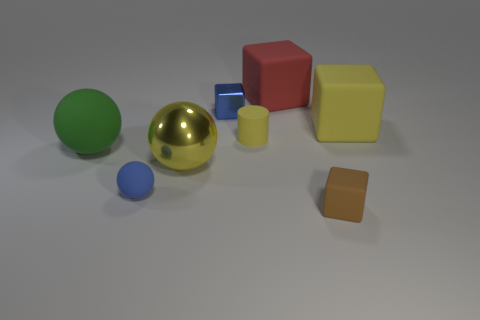What number of rubber objects are either big yellow things or big blocks?
Make the answer very short. 2. What number of other big metal things are the same color as the big metal object?
Your response must be concise. 0. What is the material of the tiny cube that is on the right side of the shiny object behind the large green object?
Give a very brief answer. Rubber. The cylinder has what size?
Make the answer very short. Small. What number of green matte balls have the same size as the red rubber thing?
Offer a terse response. 1. How many other big things have the same shape as the brown thing?
Your answer should be compact. 2. Is the number of big yellow matte objects to the left of the cylinder the same as the number of objects?
Ensure brevity in your answer.  No. Are there any other things that are the same size as the red object?
Your answer should be very brief. Yes. There is a yellow metallic thing that is the same size as the green object; what shape is it?
Your answer should be very brief. Sphere. Are there any small blue metallic objects of the same shape as the brown object?
Make the answer very short. Yes. 